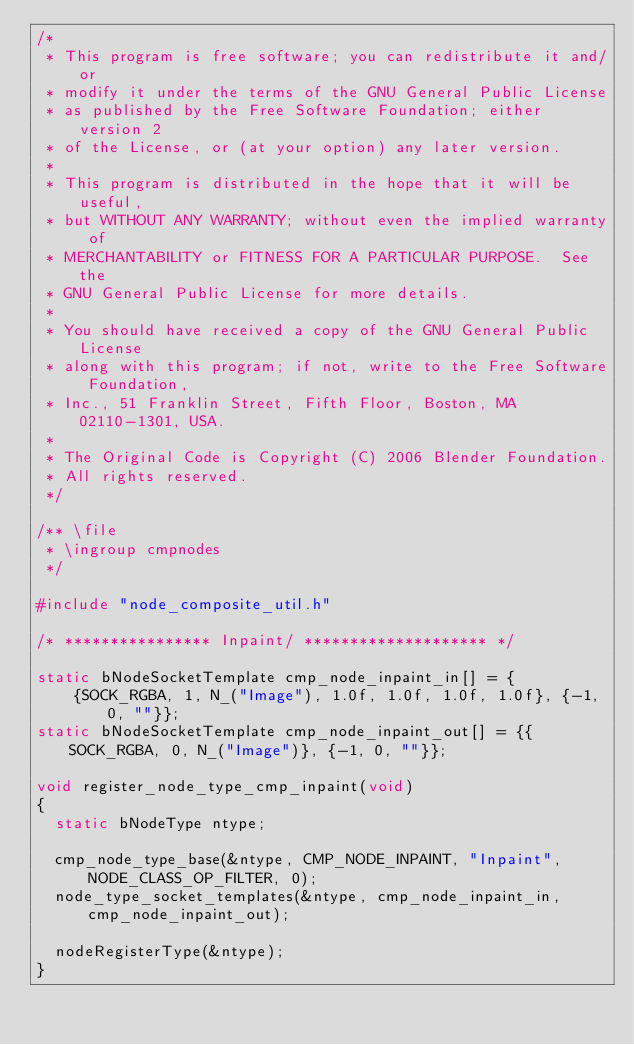Convert code to text. <code><loc_0><loc_0><loc_500><loc_500><_C_>/*
 * This program is free software; you can redistribute it and/or
 * modify it under the terms of the GNU General Public License
 * as published by the Free Software Foundation; either version 2
 * of the License, or (at your option) any later version.
 *
 * This program is distributed in the hope that it will be useful,
 * but WITHOUT ANY WARRANTY; without even the implied warranty of
 * MERCHANTABILITY or FITNESS FOR A PARTICULAR PURPOSE.  See the
 * GNU General Public License for more details.
 *
 * You should have received a copy of the GNU General Public License
 * along with this program; if not, write to the Free Software Foundation,
 * Inc., 51 Franklin Street, Fifth Floor, Boston, MA 02110-1301, USA.
 *
 * The Original Code is Copyright (C) 2006 Blender Foundation.
 * All rights reserved.
 */

/** \file
 * \ingroup cmpnodes
 */

#include "node_composite_util.h"

/* **************** Inpaint/ ******************** */

static bNodeSocketTemplate cmp_node_inpaint_in[] = {
    {SOCK_RGBA, 1, N_("Image"), 1.0f, 1.0f, 1.0f, 1.0f}, {-1, 0, ""}};
static bNodeSocketTemplate cmp_node_inpaint_out[] = {{SOCK_RGBA, 0, N_("Image")}, {-1, 0, ""}};

void register_node_type_cmp_inpaint(void)
{
  static bNodeType ntype;

  cmp_node_type_base(&ntype, CMP_NODE_INPAINT, "Inpaint", NODE_CLASS_OP_FILTER, 0);
  node_type_socket_templates(&ntype, cmp_node_inpaint_in, cmp_node_inpaint_out);

  nodeRegisterType(&ntype);
}
</code> 